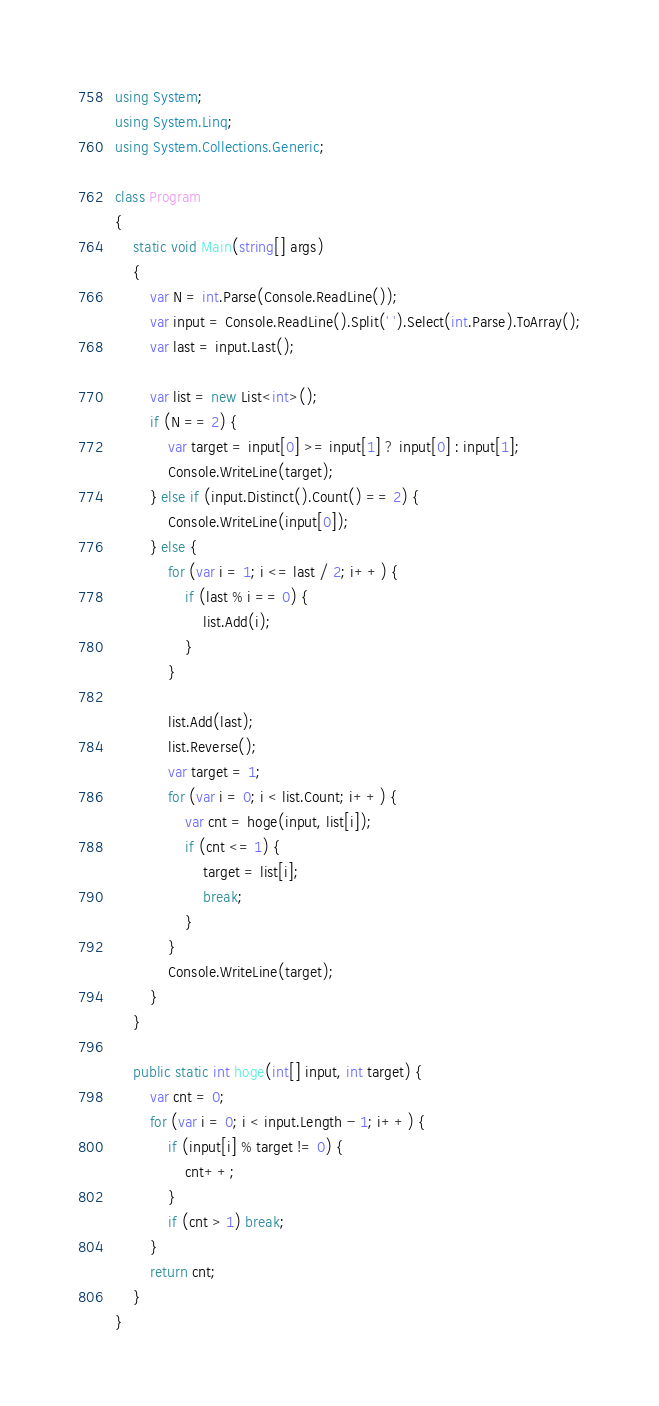<code> <loc_0><loc_0><loc_500><loc_500><_C#_>using System;
using System.Linq;
using System.Collections.Generic;

class Program
{
    static void Main(string[] args)
    {
        var N = int.Parse(Console.ReadLine());
        var input = Console.ReadLine().Split(' ').Select(int.Parse).ToArray();
        var last = input.Last();
        
        var list = new List<int>();
        if (N == 2) {
            var target = input[0] >= input[1] ? input[0] : input[1];
            Console.WriteLine(target);
        } else if (input.Distinct().Count() == 2) {
            Console.WriteLine(input[0]);
        } else {
            for (var i = 1; i <= last / 2; i++) {
                if (last % i == 0) {
                    list.Add(i);
                }
            }
            
            list.Add(last);
            list.Reverse();
            var target = 1;
            for (var i = 0; i < list.Count; i++) {
                var cnt = hoge(input, list[i]);
                if (cnt <= 1) {
                    target = list[i];
                    break;
                }
            }            
            Console.WriteLine(target);
        }
    }
    
    public static int hoge(int[] input, int target) {
        var cnt = 0;
        for (var i = 0; i < input.Length - 1; i++) {
            if (input[i] % target != 0) {
                cnt++;
            }
            if (cnt > 1) break;
        }
        return cnt;
    }
}
</code> 